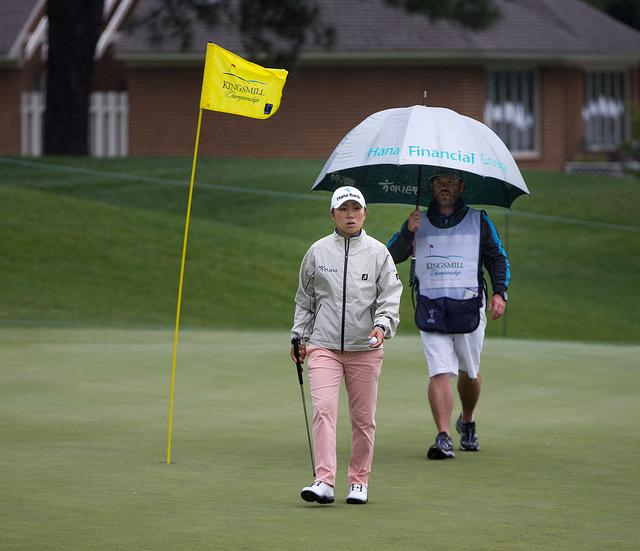What are they doing?

Choices:
A) stealing balls
B) leaving
C) arguing
D) golfing golfing 